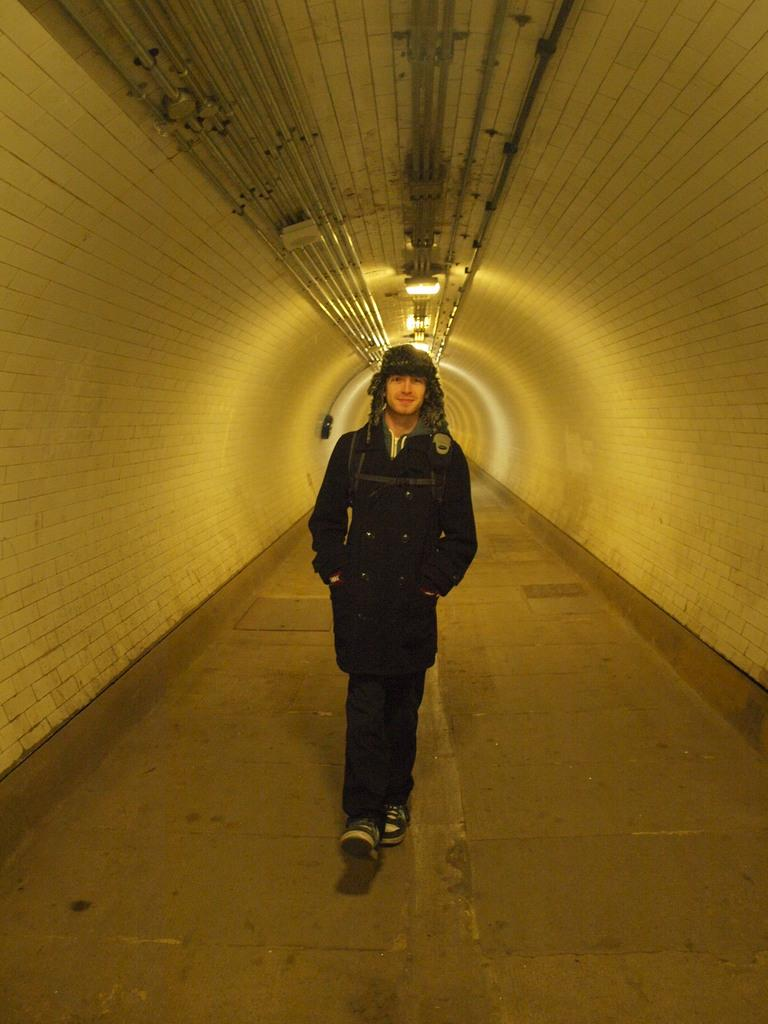Who is present in the image? There is a person in the image. What is the person doing in the image? The person is walking on the road. What can be seen on either side of the person? There are walls beside the person. What type of sail can be seen in the image? There is no sail present in the image. What scene is depicted in the image? The image depicts a person walking on the road with walls on either side. 